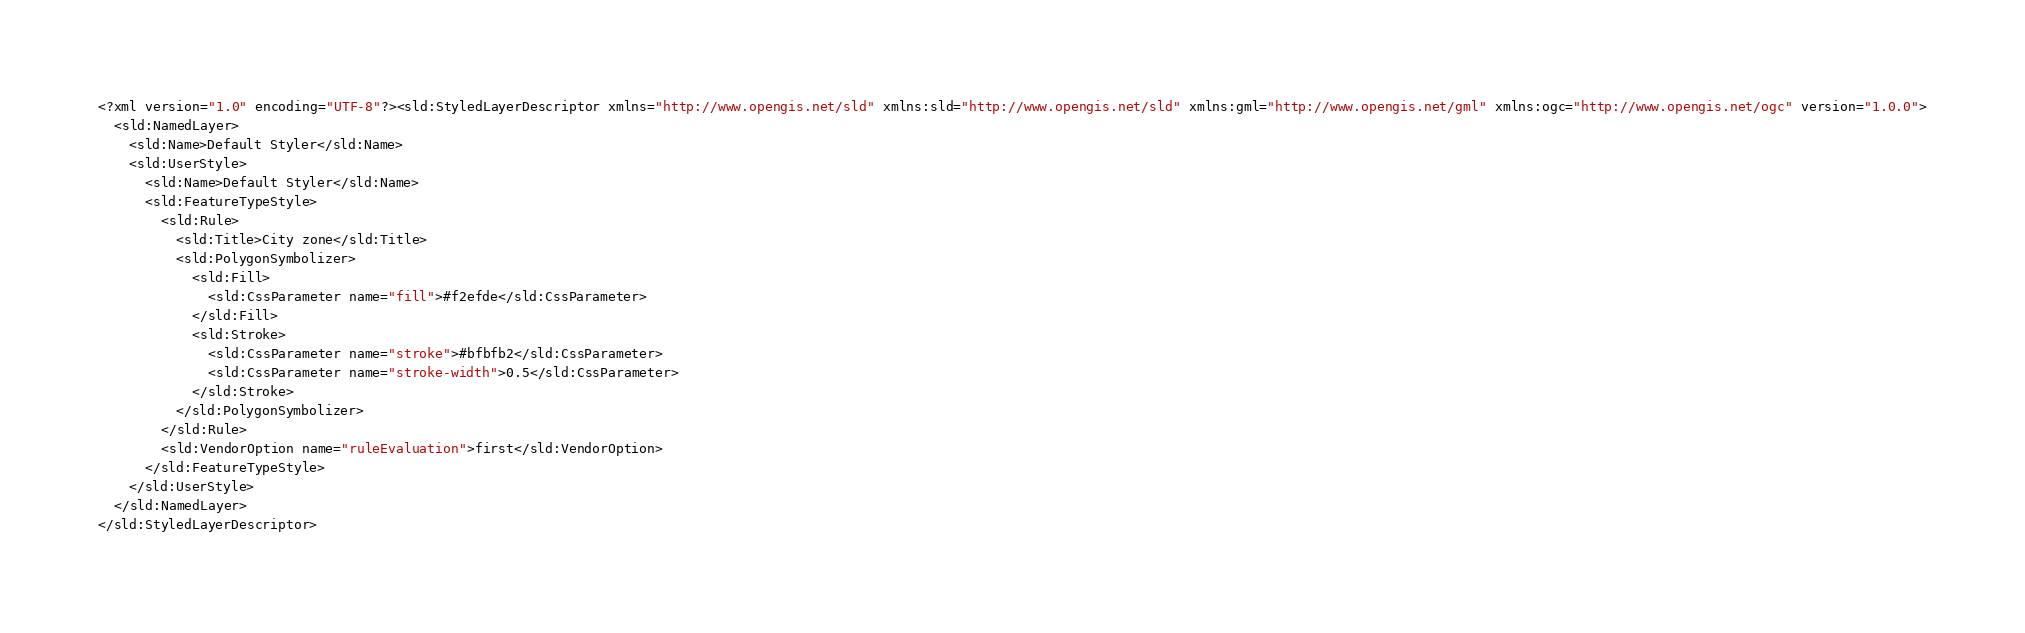Convert code to text. <code><loc_0><loc_0><loc_500><loc_500><_Scheme_><?xml version="1.0" encoding="UTF-8"?><sld:StyledLayerDescriptor xmlns="http://www.opengis.net/sld" xmlns:sld="http://www.opengis.net/sld" xmlns:gml="http://www.opengis.net/gml" xmlns:ogc="http://www.opengis.net/ogc" version="1.0.0">
  <sld:NamedLayer>
    <sld:Name>Default Styler</sld:Name>
    <sld:UserStyle>
      <sld:Name>Default Styler</sld:Name>
      <sld:FeatureTypeStyle>
        <sld:Rule>
          <sld:Title>City zone</sld:Title>
          <sld:PolygonSymbolizer>
            <sld:Fill>
              <sld:CssParameter name="fill">#f2efde</sld:CssParameter>
            </sld:Fill>
            <sld:Stroke>
              <sld:CssParameter name="stroke">#bfbfb2</sld:CssParameter>
              <sld:CssParameter name="stroke-width">0.5</sld:CssParameter>
            </sld:Stroke>
          </sld:PolygonSymbolizer>
        </sld:Rule>
        <sld:VendorOption name="ruleEvaluation">first</sld:VendorOption>
      </sld:FeatureTypeStyle>
    </sld:UserStyle>
  </sld:NamedLayer>
</sld:StyledLayerDescriptor>

</code> 